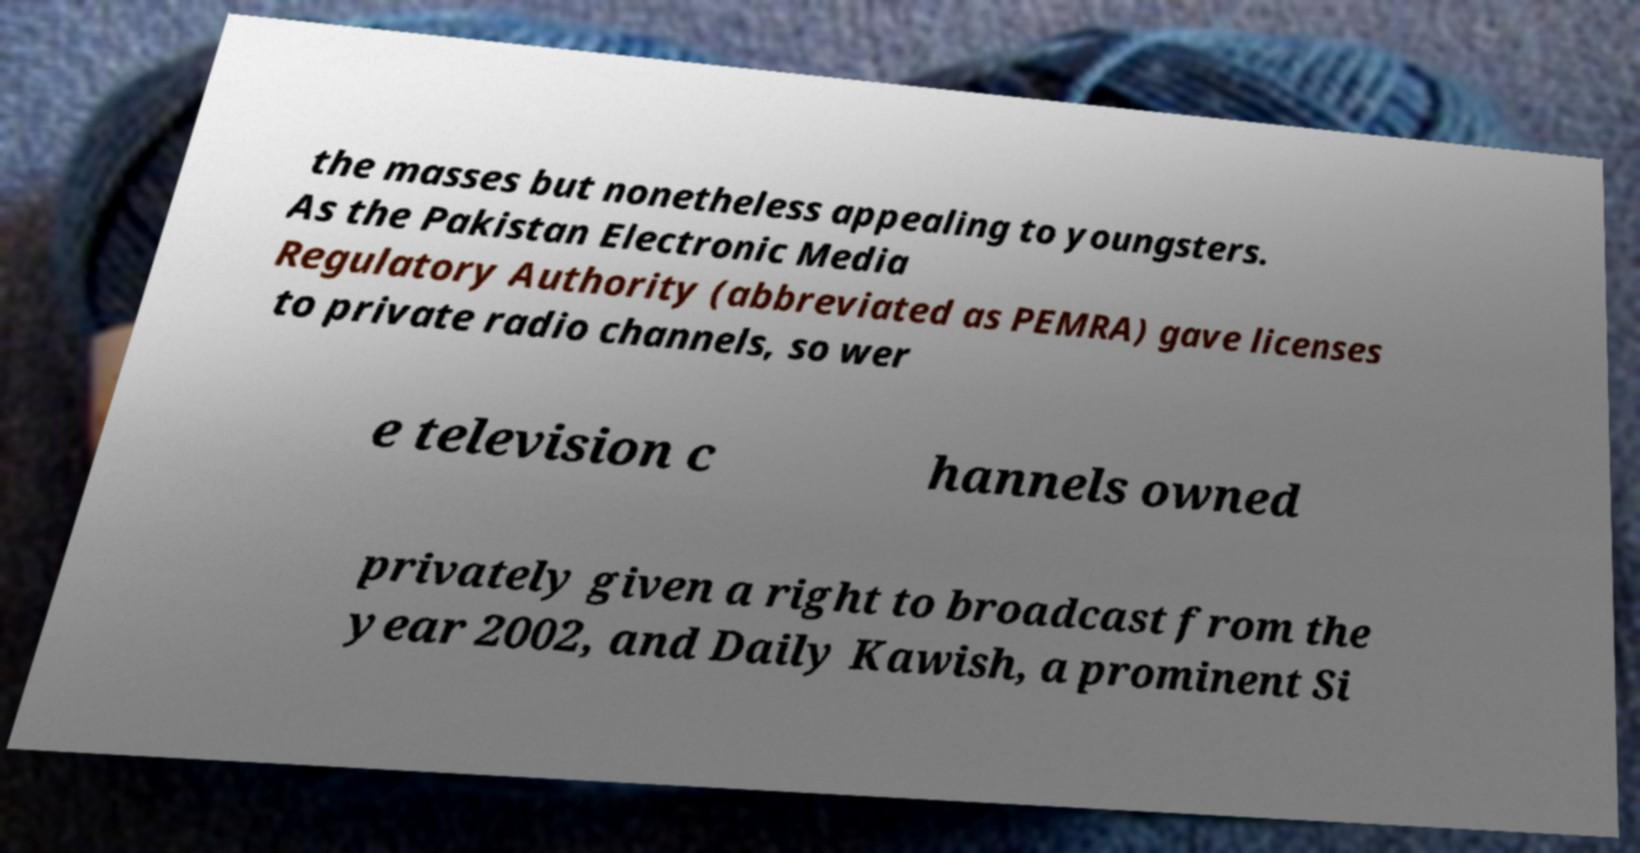For documentation purposes, I need the text within this image transcribed. Could you provide that? the masses but nonetheless appealing to youngsters. As the Pakistan Electronic Media Regulatory Authority (abbreviated as PEMRA) gave licenses to private radio channels, so wer e television c hannels owned privately given a right to broadcast from the year 2002, and Daily Kawish, a prominent Si 